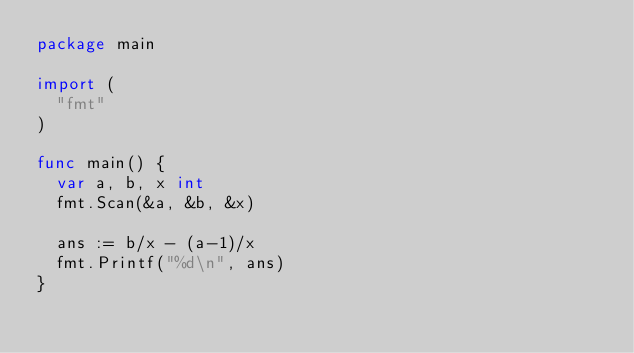<code> <loc_0><loc_0><loc_500><loc_500><_Go_>package main
 
import (
  "fmt"
)

func main() {
  var a, b, x int
  fmt.Scan(&a, &b, &x)

  ans := b/x - (a-1)/x
  fmt.Printf("%d\n", ans)
}</code> 